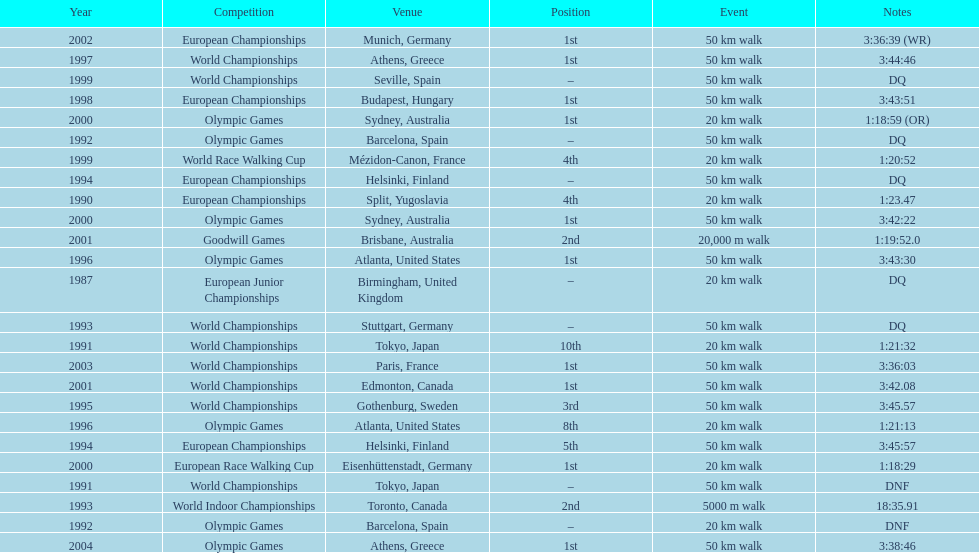How many times was korzeniowski disqualified from a competition? 5. 